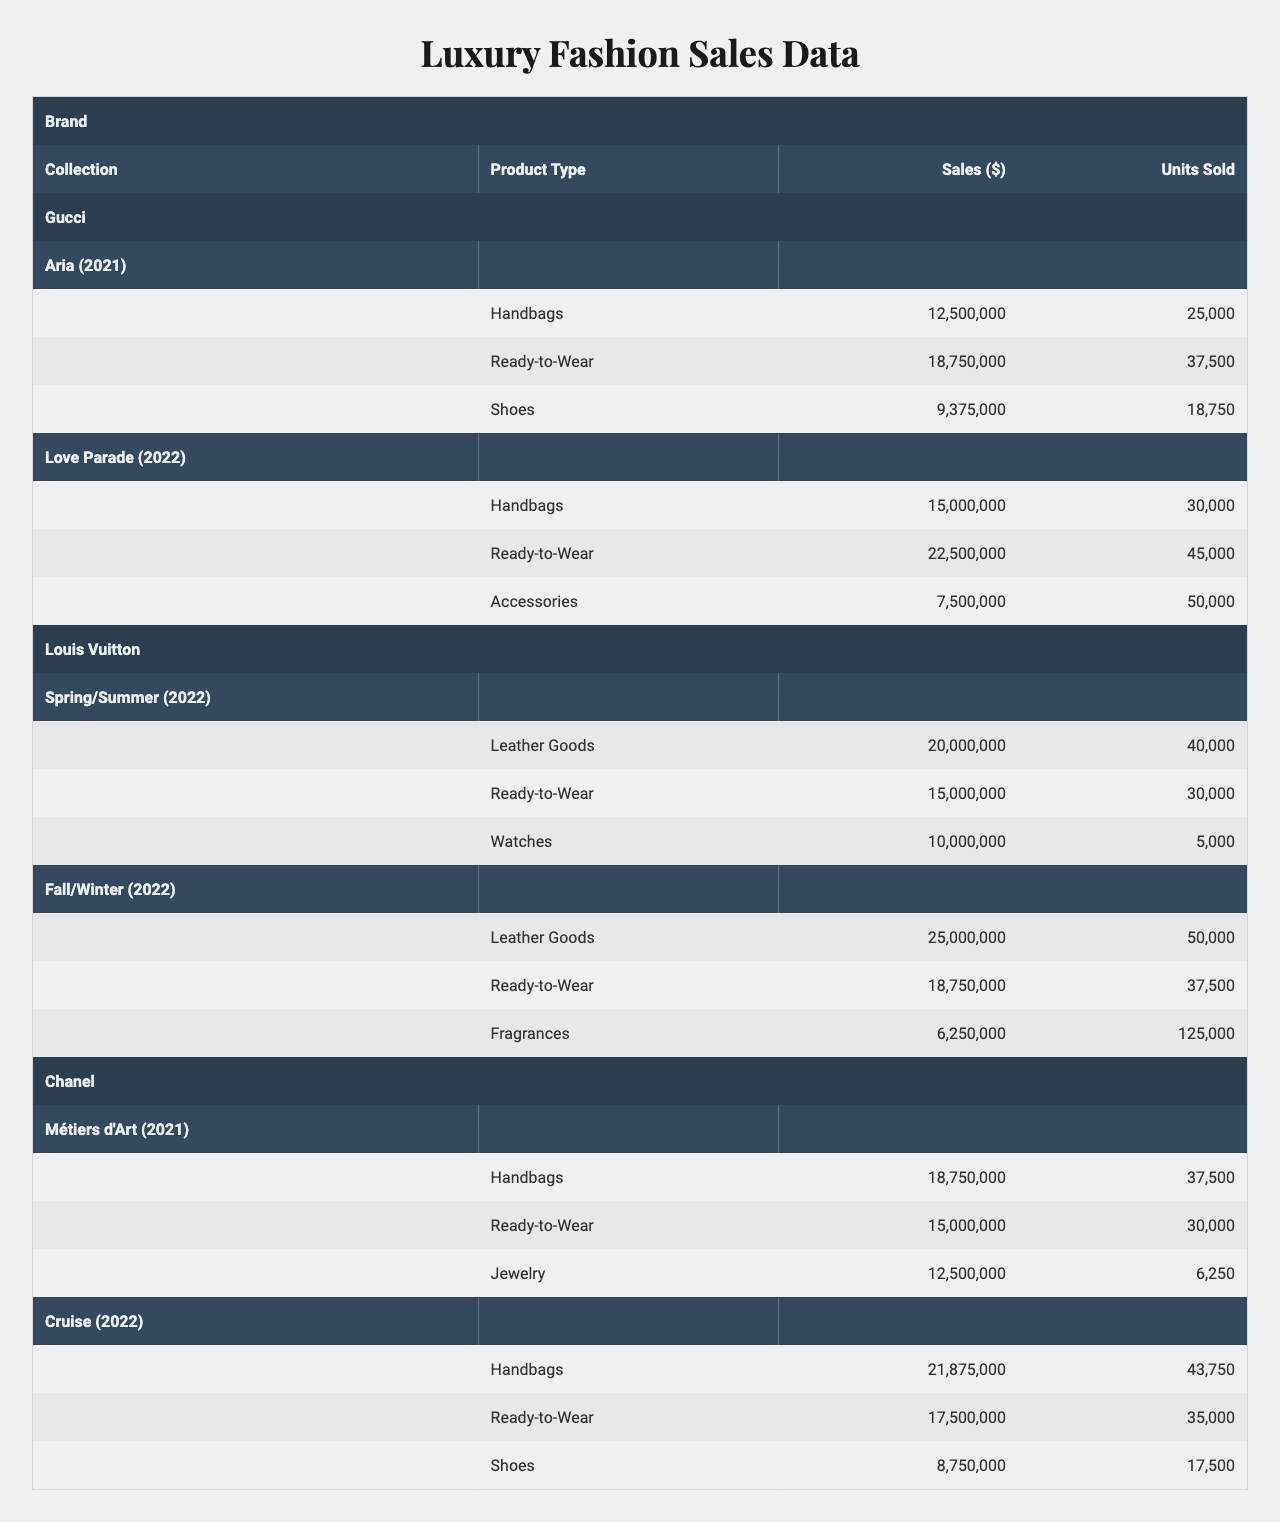What is the total sales for Gucci's "Love Parade" collection? For Gucci's "Love Parade" collection in 2022, the sales totals for each product type are Handbags ($15,000,000), Ready-to-Wear ($22,500,000), and Accessories ($7,500,000). Adding these together gives: 15,000,000 + 22,500,000 + 7,500,000 = 45,000,000.
Answer: 45,000,000 Which brand had the highest sales in the "Cruise" collection? Chanel's "Cruise" collection in 2022 had total sales of Handbags ($21,875,000), Ready-to-Wear ($17,500,000), and Shoes ($8,750,000). The highest individual sales type is Handbags at $21,875,000. Since Chanel is the only brand with this collection, the answer is straightforward.
Answer: Chanel How many units of "Ready-to-Wear" were sold by Louis Vuitton in 2022? Louis Vuitton has two collections in 2022: "Spring/Summer" with 30,000 units sold for Ready-to-Wear, and "Fall/Winter" with 37,500 units sold. Adding these gives: 30,000 + 37,500 = 67,500 units.
Answer: 67,500 What was the average sales of handbags across all collections for Chanel? Chanel has two collections with Handbag sales: "Métiers d'Art" ($18,750,000) in 2021 and "Cruise" ($21,875,000) in 2022. The total sales of handbags is 18,750,000 + 21,875,000 = 40,625,000 and there are 2 data points. The average is calculated as: 40,625,000 / 2 = 20,312,500.
Answer: 20,312,500 Did Louis Vuitton sell more units of "Leather Goods" or "Ready-to-Wear" in 2022? For Louis Vuitton's 2022 "Spring/Summer" collection, Leather Goods sold 40,000 units and Ready-to-Wear sold 30,000 units. In the "Fall/Winter" collection, Leather Goods sold 50,000 units and Ready-to-Wear sold 37,500 units. Adding these gives Leather Goods: 40,000 + 50,000 = 90,000 and Ready-to-Wear: 30,000 + 37,500 = 67,500. Since 90,000 > 67,500, the answer is yes, Louis Vuitton sold more units of Leather Goods.
Answer: Yes Which product type had the lowest sales in the "Fall/Winter" collection by Louis Vuitton? In the "Fall/Winter" collection by Louis Vuitton, the sales for each product type are: Leather Goods ($25,000,000), Ready-to-Wear ($18,750,000), and Fragrances ($6,250,000). The lowest sales amount is for Fragrances at $6,250,000.
Answer: Fragrances How much did Chanel's "Métiers d'Art" collection earn from sales of Ready-to-Wear? In the "Métiers d'Art" collection, the sales for Ready-to-Wear is recorded as $15,000,000. There are no additional calculations needed as it is a direct retrieval of data from the table.
Answer: 15,000,000 What was the total sales across all accessory types for Gucci? Gucci has a total of two accessory types: from the "Aria" collection Handbags ($12,500,000), Ready-to-Wear ($18,750,000), and Shoes ($9,375,000) totaling $12,500,000 + $18,750,000 + $9,375,000 = $40,625,000 for "Aria". In the "Love Parade," the total is Handbags ($15,000,000), Ready-to-Wear ($22,500,000), and Accessories ($7,500,000) totaling $15,000,000 + $22,500,000 + $7,500,000 = $45,000,000. Adding totals gives \( 40,625,000 + 45,000,000 = 85,625,000 \).
Answer: 85,625,000 Which designer brand had total sales exceeding $60 million across all collections? Calculating total sales for each brand: Gucci has 'Aria' ($40,625,000) and 'Love Parade' ($45,000,000) giving $85,625,000. Louis Vuitton has 'Spring/Summer' ($40,000,000) and 'Fall/Winter' ($31,250,000) totaling $70,000,000. Chanel has 'Métiers d'Art' ($40,625,000) and 'Cruise' ($44,062,500) totaling $62,687,500. All three exceed $60 million.
Answer: All three brands What percent of total sales for the "Spring/Summer" collection from Louis Vuitton came from Ready-to-Wear? The "Spring/Summer" collection sales total is $20,000,000 (Leather Goods) + $15,000,000 (Ready-to-Wear) + $10,000,000 (Watches) = $45,000,000. Ready-to-Wear sales are $15,000,000. The percent is calculated as: \( (15,000,000 / 45,000,000) \times 100 = 33.33 \).
Answer: 33.33% 